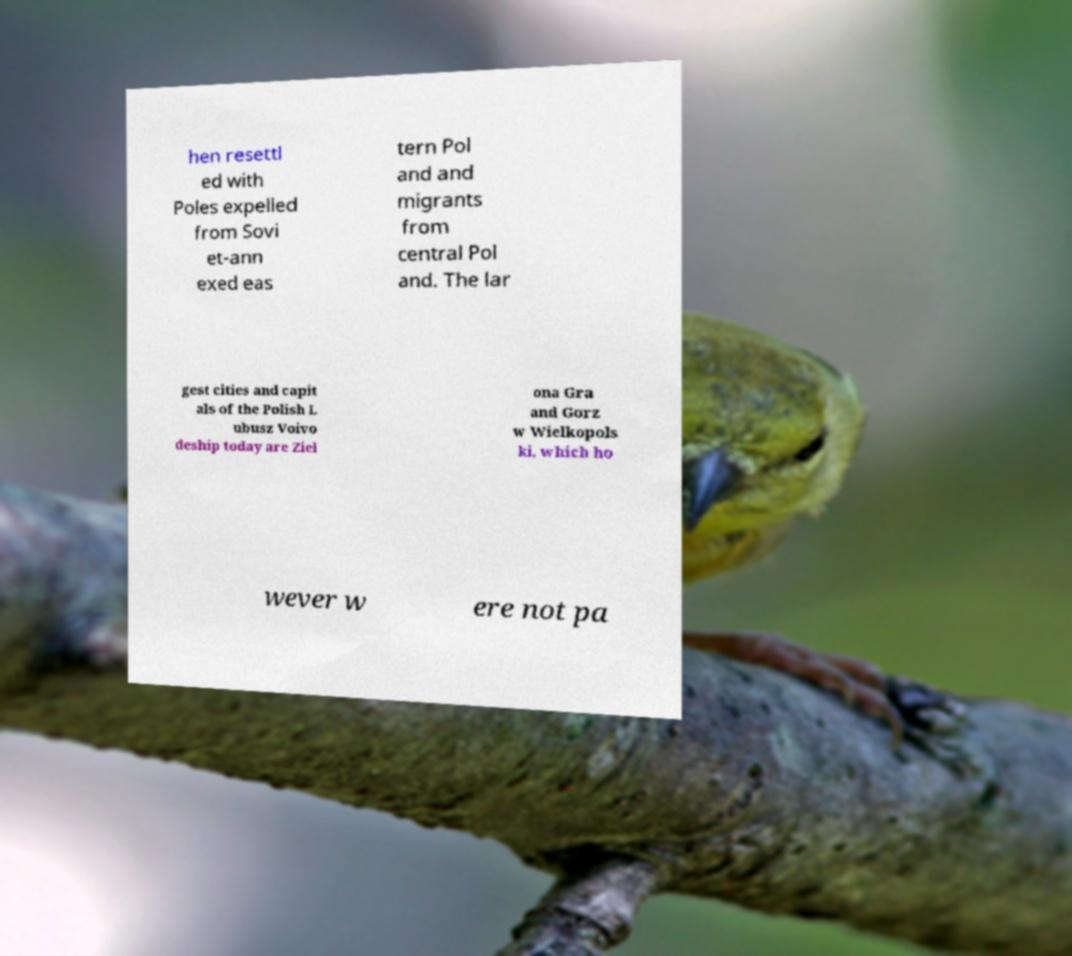There's text embedded in this image that I need extracted. Can you transcribe it verbatim? hen resettl ed with Poles expelled from Sovi et-ann exed eas tern Pol and and migrants from central Pol and. The lar gest cities and capit als of the Polish L ubusz Voivo deship today are Ziel ona Gra and Gorz w Wielkopols ki, which ho wever w ere not pa 